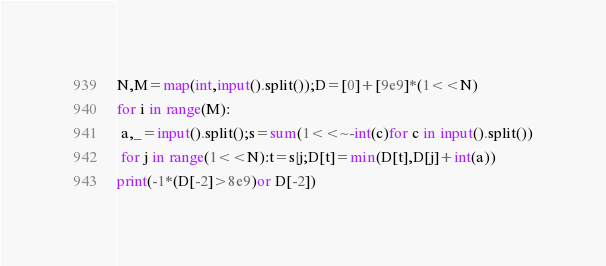Convert code to text. <code><loc_0><loc_0><loc_500><loc_500><_Python_>N,M=map(int,input().split());D=[0]+[9e9]*(1<<N)
for i in range(M):
 a,_=input().split();s=sum(1<<~-int(c)for c in input().split())
 for j in range(1<<N):t=s|j;D[t]=min(D[t],D[j]+int(a))
print(-1*(D[-2]>8e9)or D[-2])</code> 